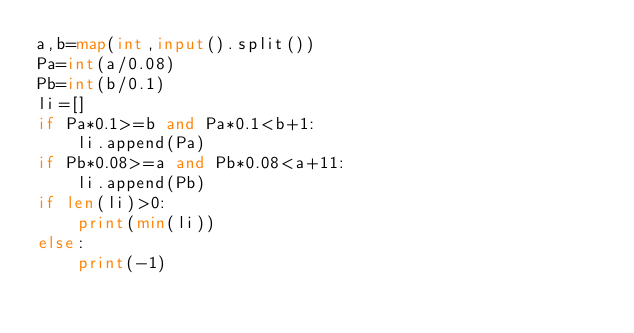<code> <loc_0><loc_0><loc_500><loc_500><_Python_>a,b=map(int,input().split())
Pa=int(a/0.08)
Pb=int(b/0.1)
li=[]
if Pa*0.1>=b and Pa*0.1<b+1:
    li.append(Pa)
if Pb*0.08>=a and Pb*0.08<a+11:
    li.append(Pb)
if len(li)>0:
    print(min(li))
else:
    print(-1)</code> 